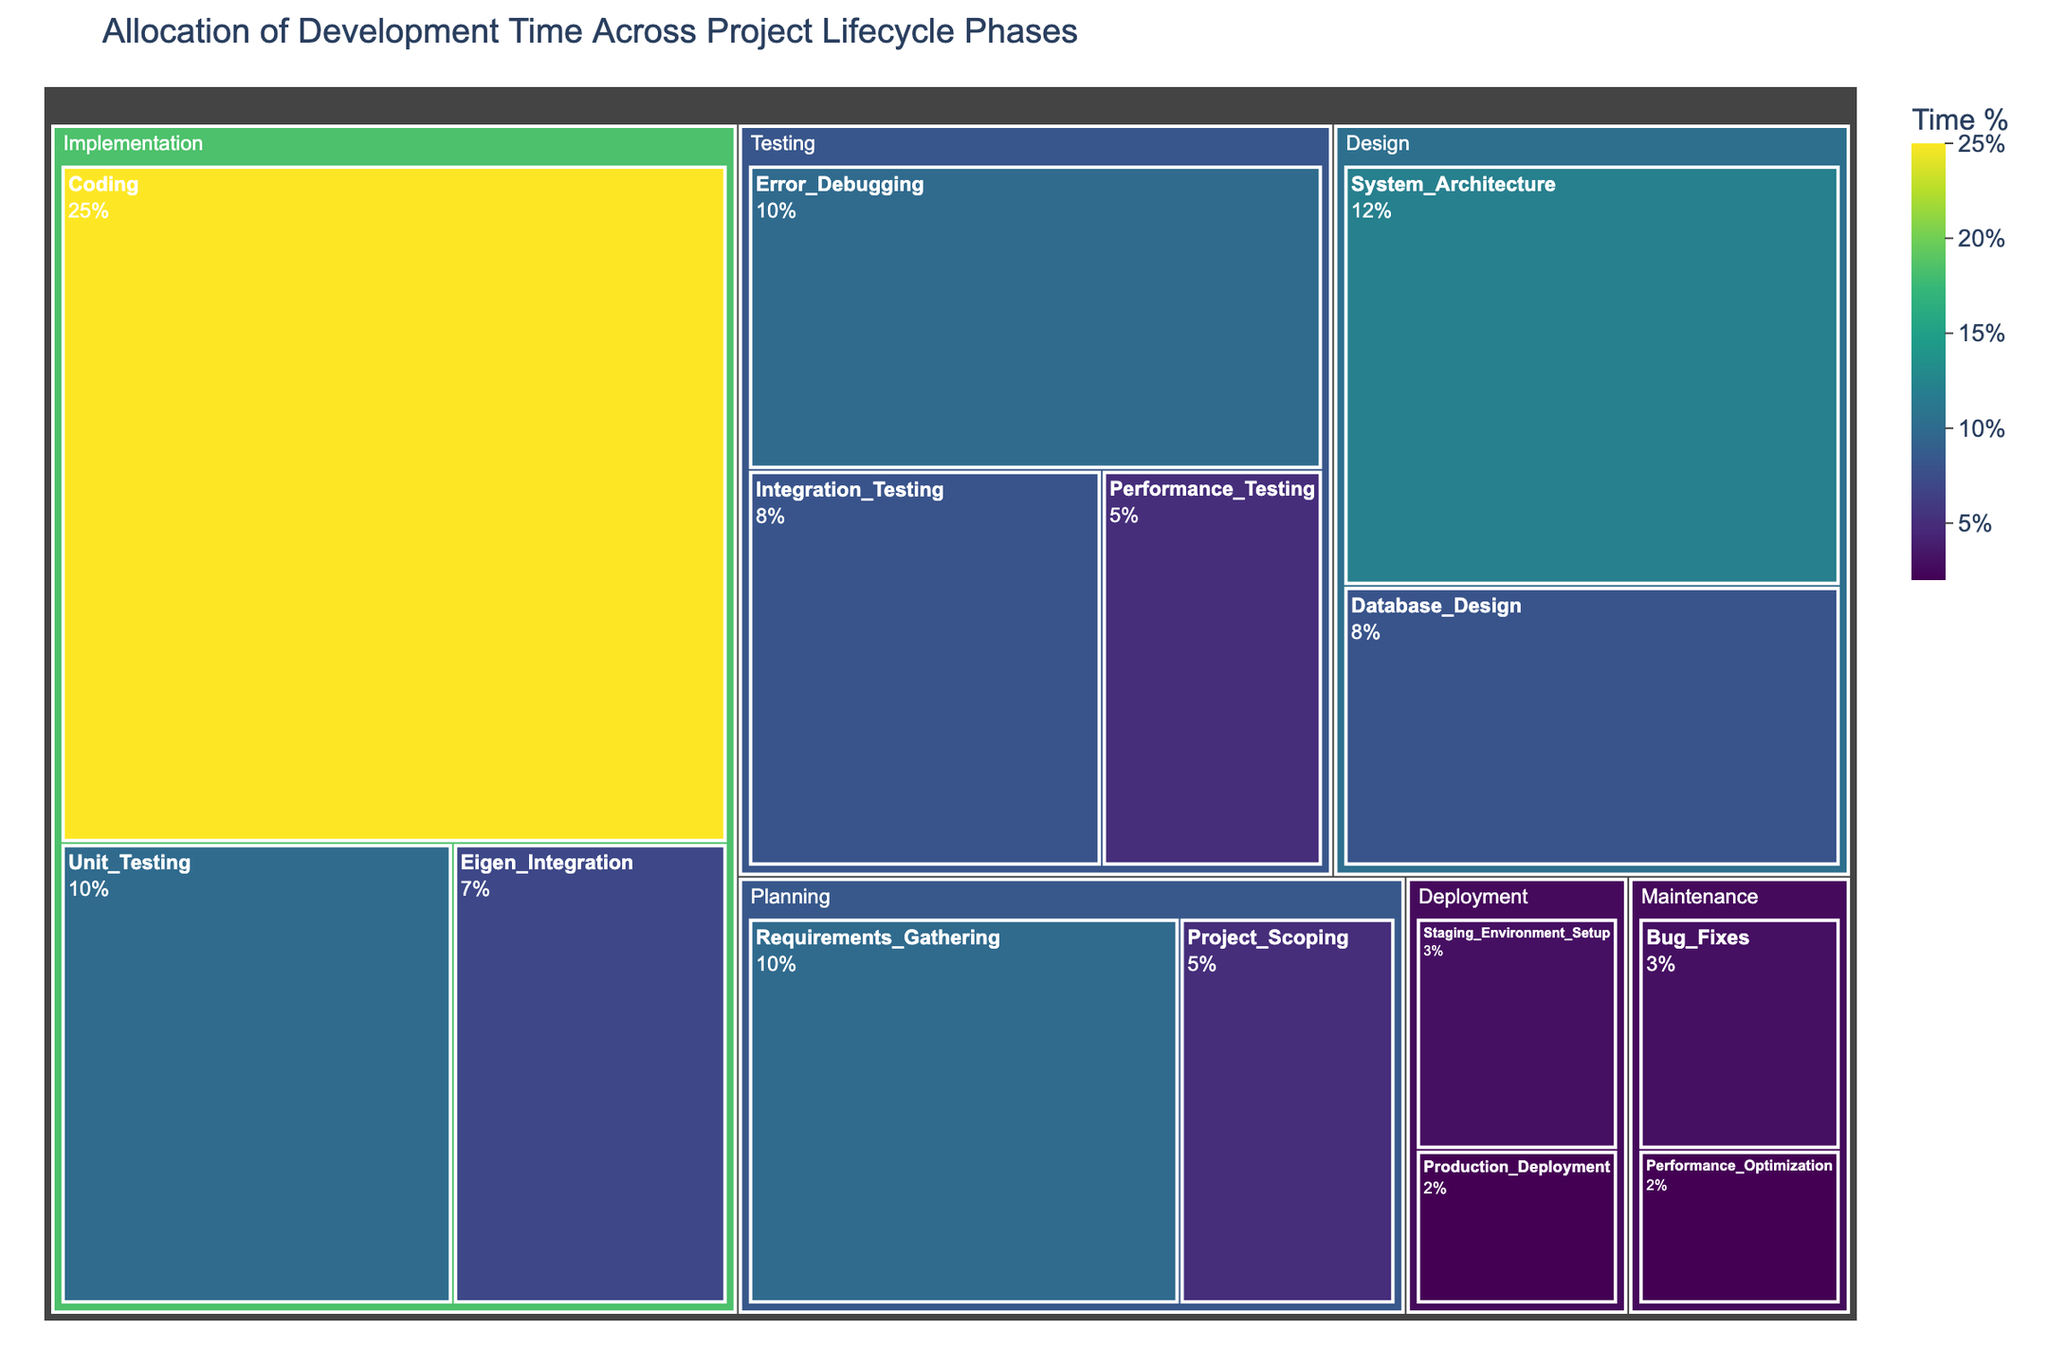What's the title of the treemap? The title is displayed at the top of the figure and provides a summary of what the chart is about.
Answer: Allocation of Development Time Across Project Lifecycle Phases Which phase takes the most development time? By looking at the size of the tiles in the treemap, the largest tile indicates the phase that takes the most time. The Implementation phase occupies the largest area.
Answer: Implementation How much time percentage is allocated to the Design phase? To find this, sum the percentages of all activities under the Design phase. That is 12% for System Architecture + 8% for Database Design = 20%.
Answer: 20% Which two activities together make up exactly 10% of the total development time? By inspecting the percentage values in the figure, two activities that sum up to 10% are Project Scoping (5%) and Performance Testing (5%).
Answer: Project Scoping and Performance Testing How does Eigen Integration compare to Bug Fixes in terms of time allocation? Compare the percentage values of both activities. Eigen Integration is 7%, while Bug Fixes is 3%.
Answer: Eigen Integration has more time allocated than Bug Fixes Which activity in the Testing phase has the lowest time allocation? Look at the activities within the Testing phase and compare their percentages. Performance Testing is 5%, which is the lowest among the Testing activities.
Answer: Performance Testing What percentage of time is spent in Maintenance? Add the time percentages of all activities within the Maintenance phase. That gives Bug Fixes 3% + Performance Optimization 2% = 5%.
Answer: 5% If we combine Coding and Unit Testing, what is their total time allocation? Adding the percentages for Coding and Unit Testing gives 25% + 10% = 35%.
Answer: 35% Which phase includes the most diversified activities and how many activities are there? Count the number of activities under each phase. The Implementation phase has the most diversified activities with a total of 3 activities (Coding, Unit Testing, Eigen Integration).
Answer: Implementation, 3 activities Is there any activity in the Deployment phase that takes more than 3% of the total development time? Check the Deployment phase for any activities with percentages greater than 3%. Staging Environment Setup is exactly 3%, and Production Deployment is 2%, so none exceed 3%.
Answer: No 